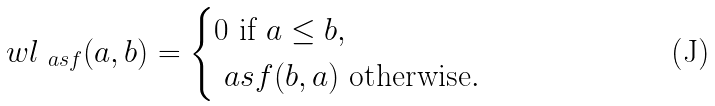Convert formula to latex. <formula><loc_0><loc_0><loc_500><loc_500>\ w l _ { \ a s f } ( a , b ) & = \begin{cases} 0 \text { if } a \leq b , \\ \ a s f ( b , a ) \text { otherwise} . \end{cases}</formula> 